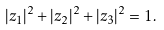Convert formula to latex. <formula><loc_0><loc_0><loc_500><loc_500>| z _ { 1 } | ^ { 2 } + | z _ { 2 } | ^ { 2 } + | z _ { 3 } | ^ { 2 } = 1 .</formula> 